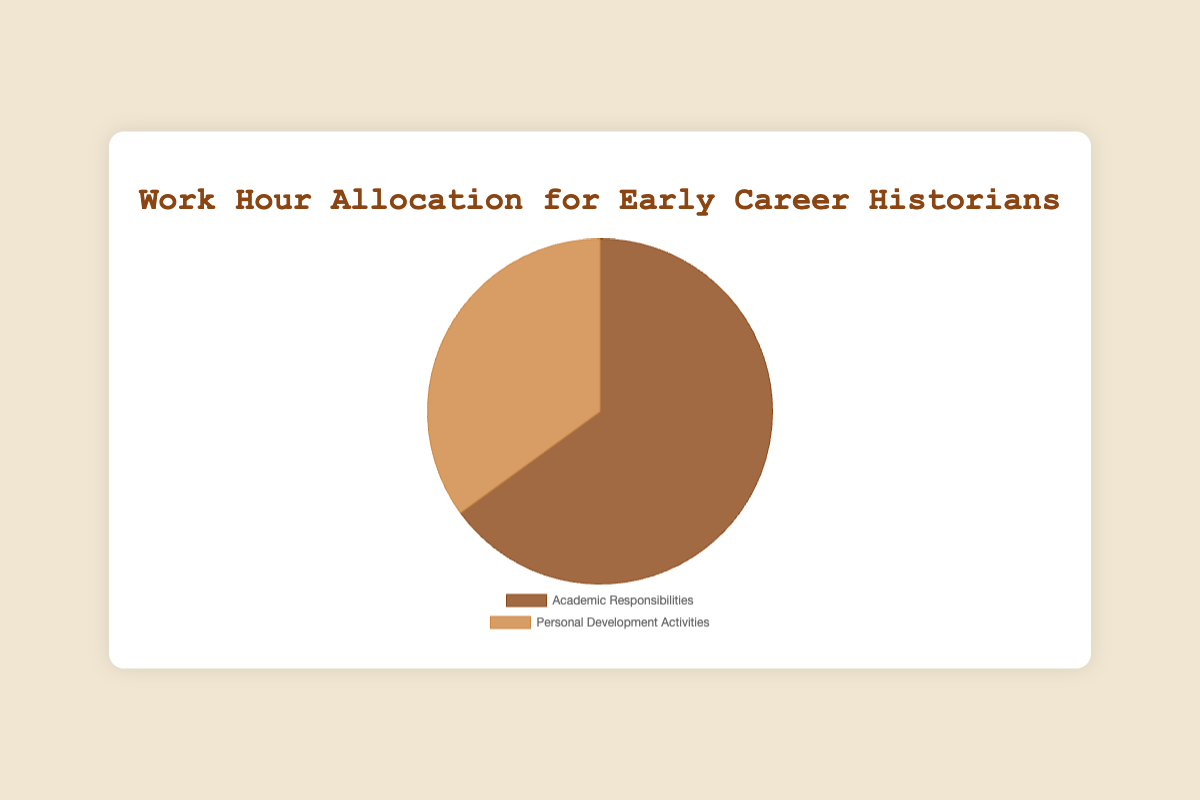What's the percentage of hours allocated to Academic Responsibilities? The pie chart shows that 65% of the work hours are allocated to Academic Responsibilities.
Answer: 65% What's the percentage of hours allocated to Personal Development Activities? The pie chart indicates that 35% of the work hours are allocated to Personal Development Activities.
Answer: 35% Which category has more hours allocated? By comparing the percentages, Academic Responsibilities has 65%, which is more than Personal Development Activities' 35%.
Answer: Academic Responsibilities How much more time is spent on Academic Responsibilities compared to Personal Development Activities? The difference between the two categories is 65% - 35% = 30%.
Answer: 30% What proportion of the total time is spent on activities other than Academic Responsibilities? Since 65% is for Academic Responsibilities, the remaining time, 100% - 65%, is 35%, which is spent on Personal Development Activities.
Answer: 35% If you combine the time spent on both categories, what's the total percentage? The total percentage for both categories is 65% + 35% = 100%.
Answer: 100% What is the ratio of time spent on Academic Responsibilities to Personal Development Activities? The ratio can be calculated as 65 : 35, which simplifies to 13 : 7.
Answer: 13 : 7 Is the proportion of Academic Responsibilities more than double the proportion of Personal Development Activities? Double the proportion of Personal Development Activities is 35% * 2 = 70%, which is more than 65%, so no, it is not more than double.
Answer: No What color represents Academic Responsibilities on the pie chart? The portion representing Academic Responsibilities is displayed in dark brown.
Answer: Dark brown What color represents Personal Development Activities on the pie chart? The portion representing Personal Development Activities is displayed in light brown.
Answer: Light brown 